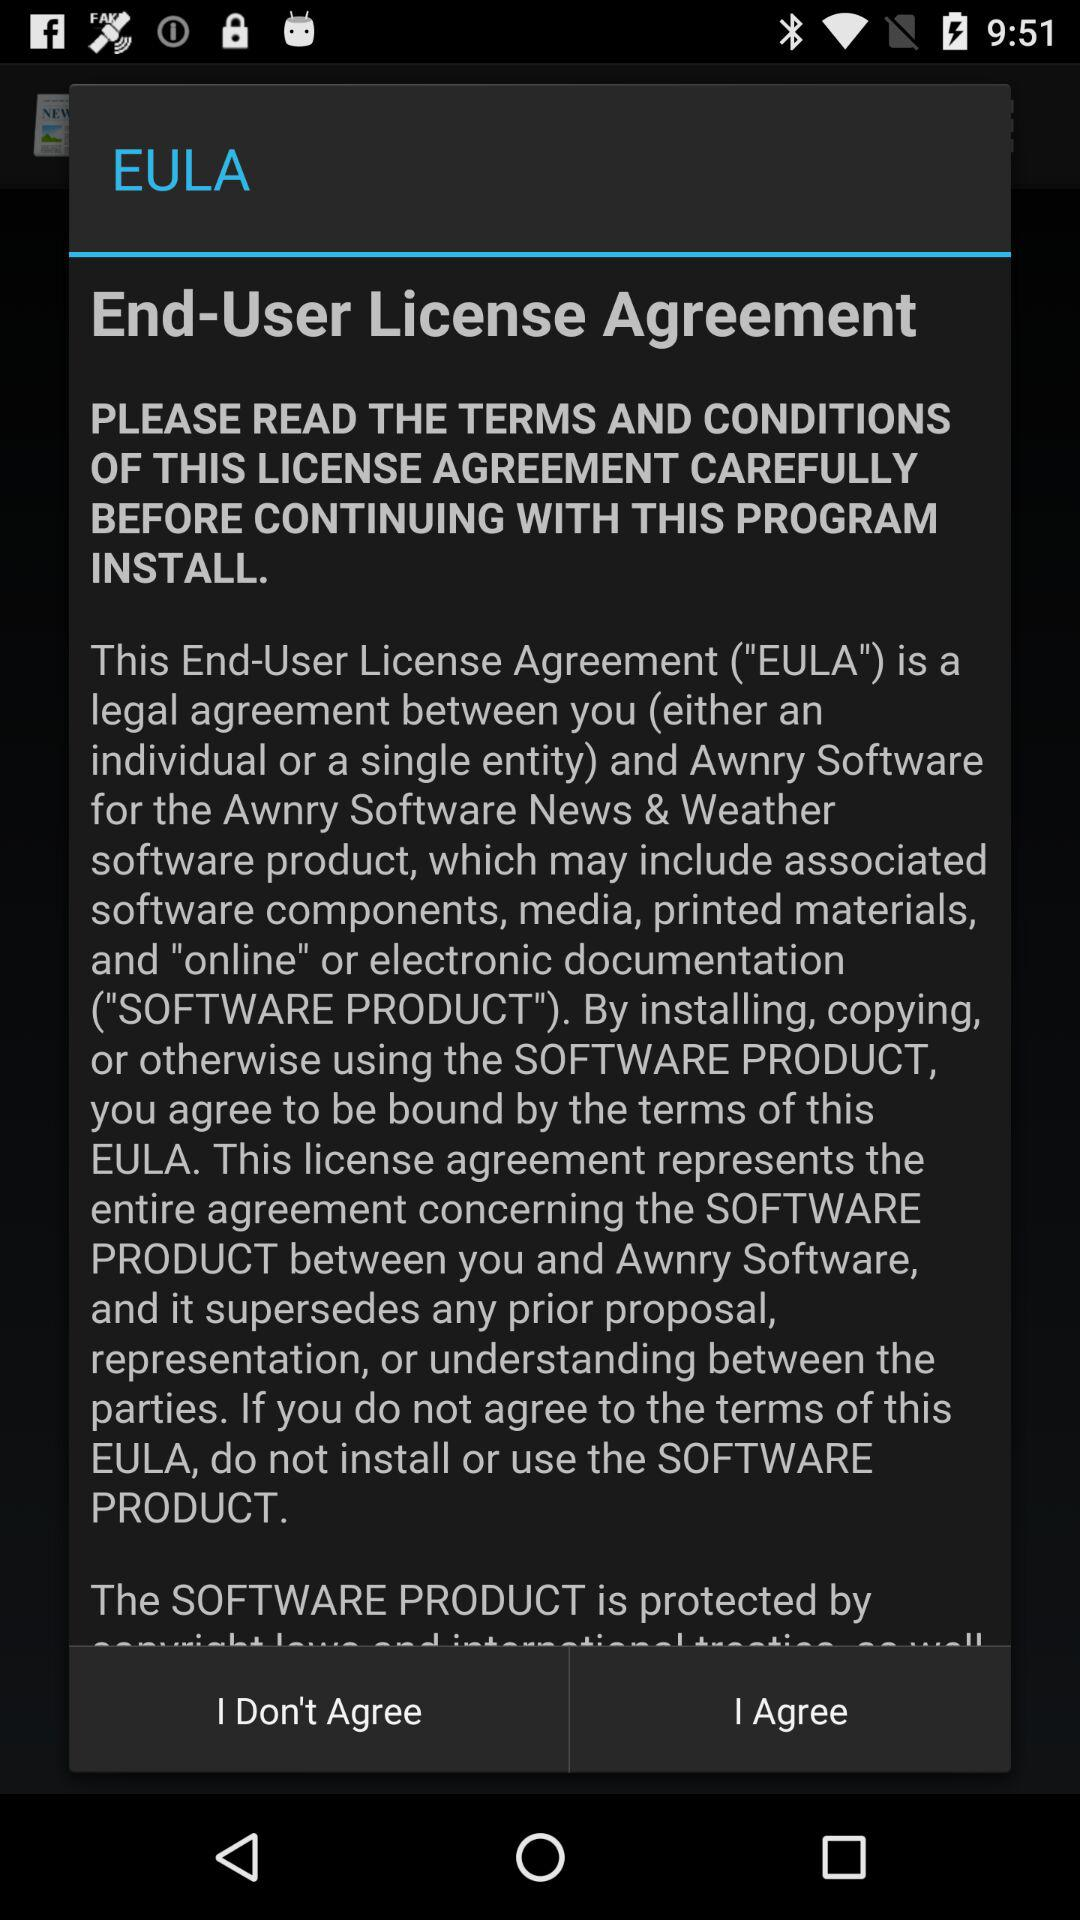What is the full form of the EULA? The full form of the EULA is "End-User License Agreement". 